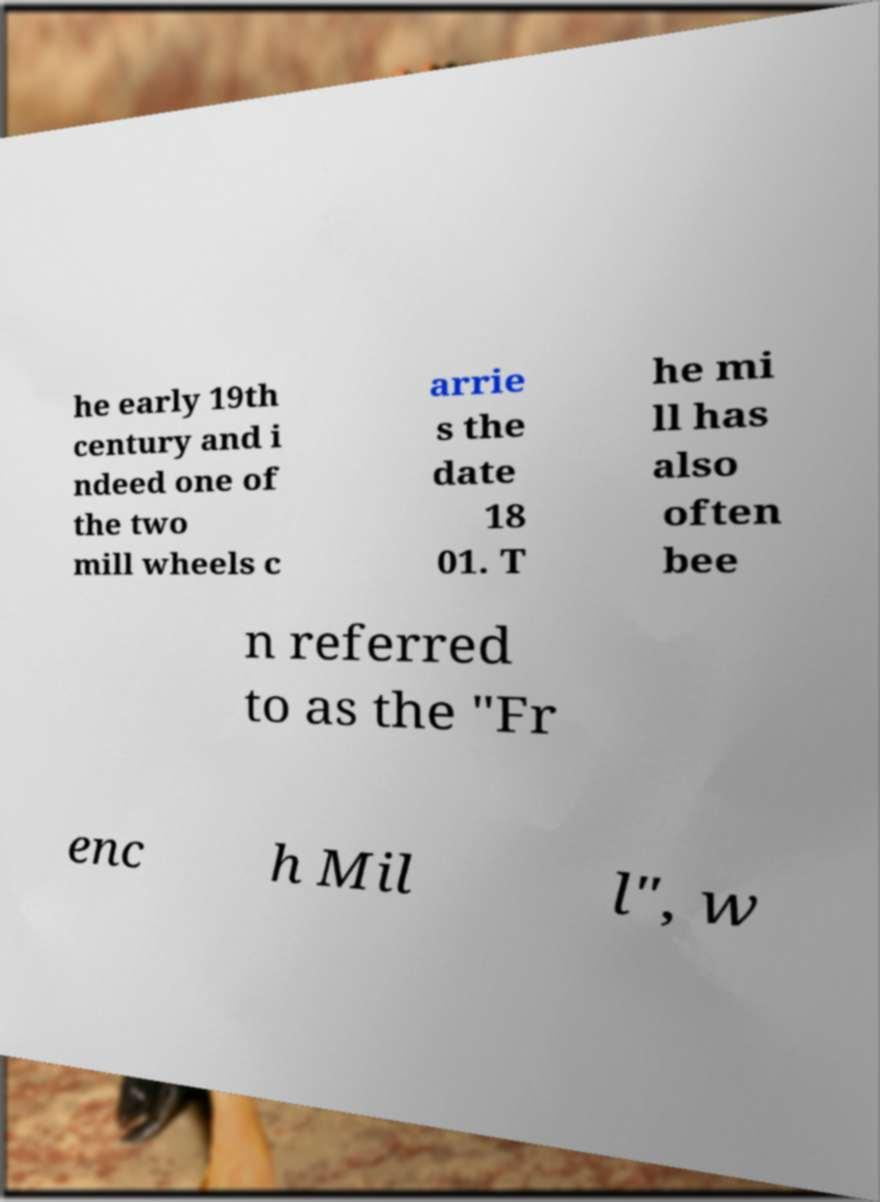Could you assist in decoding the text presented in this image and type it out clearly? he early 19th century and i ndeed one of the two mill wheels c arrie s the date 18 01. T he mi ll has also often bee n referred to as the "Fr enc h Mil l", w 